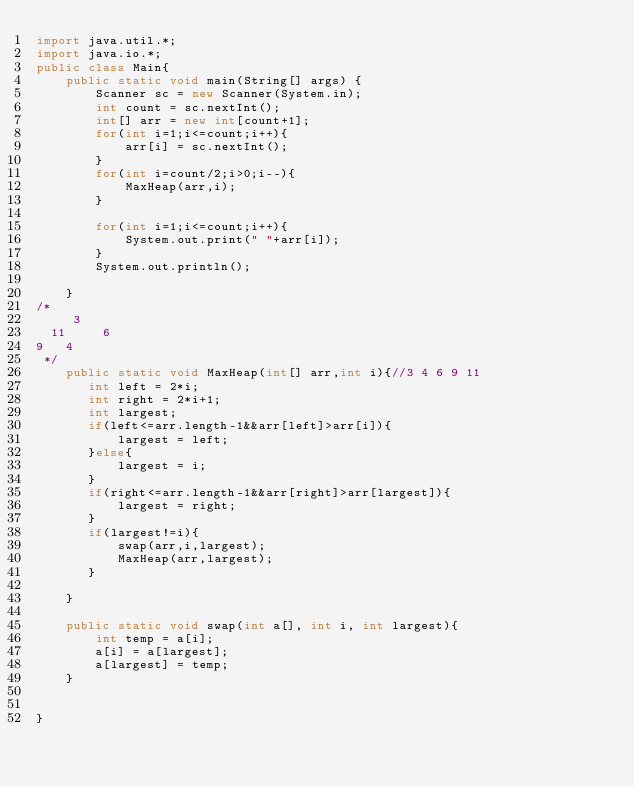<code> <loc_0><loc_0><loc_500><loc_500><_Java_>import java.util.*;
import java.io.*;
public class Main{
    public static void main(String[] args) {
        Scanner sc = new Scanner(System.in);
        int count = sc.nextInt();
        int[] arr = new int[count+1];
        for(int i=1;i<=count;i++){
            arr[i] = sc.nextInt();
        }
        for(int i=count/2;i>0;i--){
            MaxHeap(arr,i);
        }

        for(int i=1;i<=count;i++){
            System.out.print(" "+arr[i]);
        }
        System.out.println();

    }
/*
     3
  11     6
9   4
 */
    public static void MaxHeap(int[] arr,int i){//3 4 6 9 11
       int left = 2*i;
       int right = 2*i+1;
       int largest;
       if(left<=arr.length-1&&arr[left]>arr[i]){
           largest = left;
       }else{
           largest = i;
       }
       if(right<=arr.length-1&&arr[right]>arr[largest]){
           largest = right;
       }
       if(largest!=i){
           swap(arr,i,largest);
           MaxHeap(arr,largest);
       }

    }

    public static void swap(int a[], int i, int largest){
        int temp = a[i];
        a[i] = a[largest];
        a[largest] = temp;
    }


}

</code> 